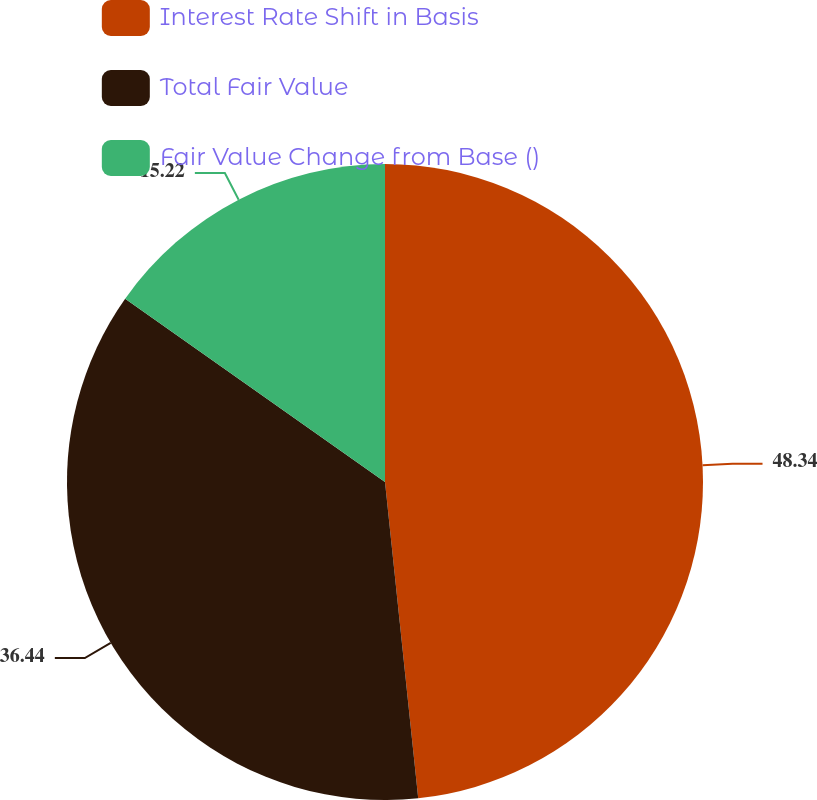<chart> <loc_0><loc_0><loc_500><loc_500><pie_chart><fcel>Interest Rate Shift in Basis<fcel>Total Fair Value<fcel>Fair Value Change from Base ()<nl><fcel>48.33%<fcel>36.44%<fcel>15.22%<nl></chart> 